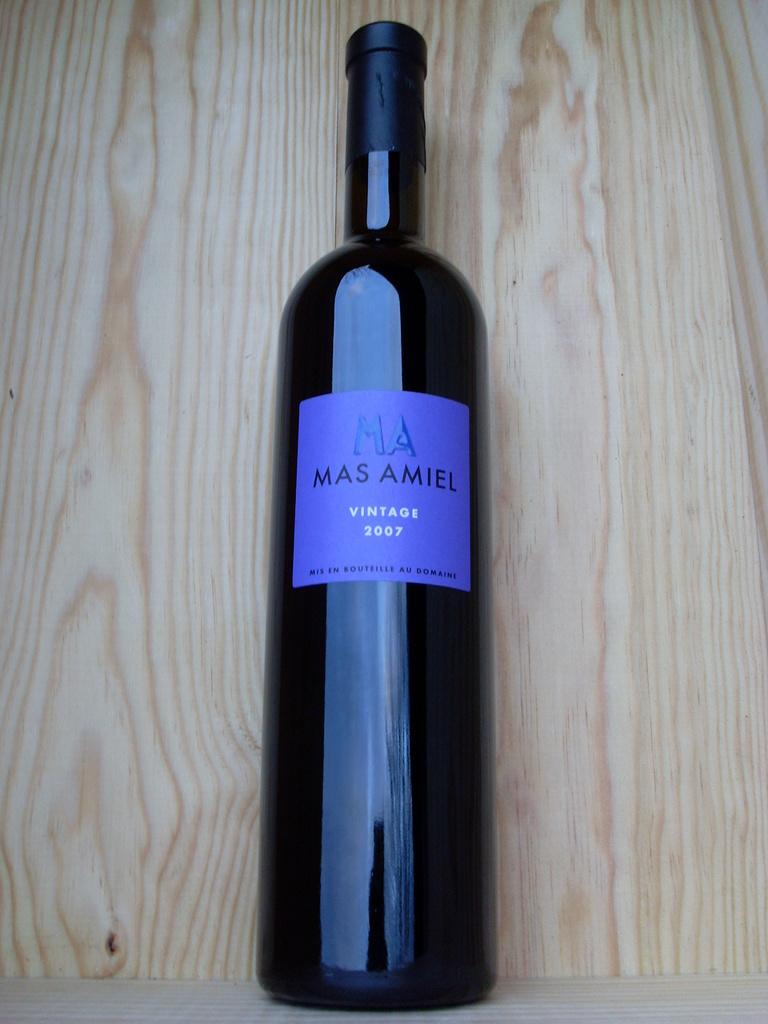What brand of wine is this?
Offer a very short reply. Mas amiel. 